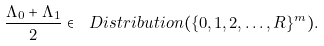Convert formula to latex. <formula><loc_0><loc_0><loc_500><loc_500>\frac { \Lambda _ { 0 } + \Lambda _ { 1 } } { 2 } \in \ D i s t r i b u t i o n ( \{ 0 , 1 , 2 , \dots , R \} ^ { m } ) .</formula> 